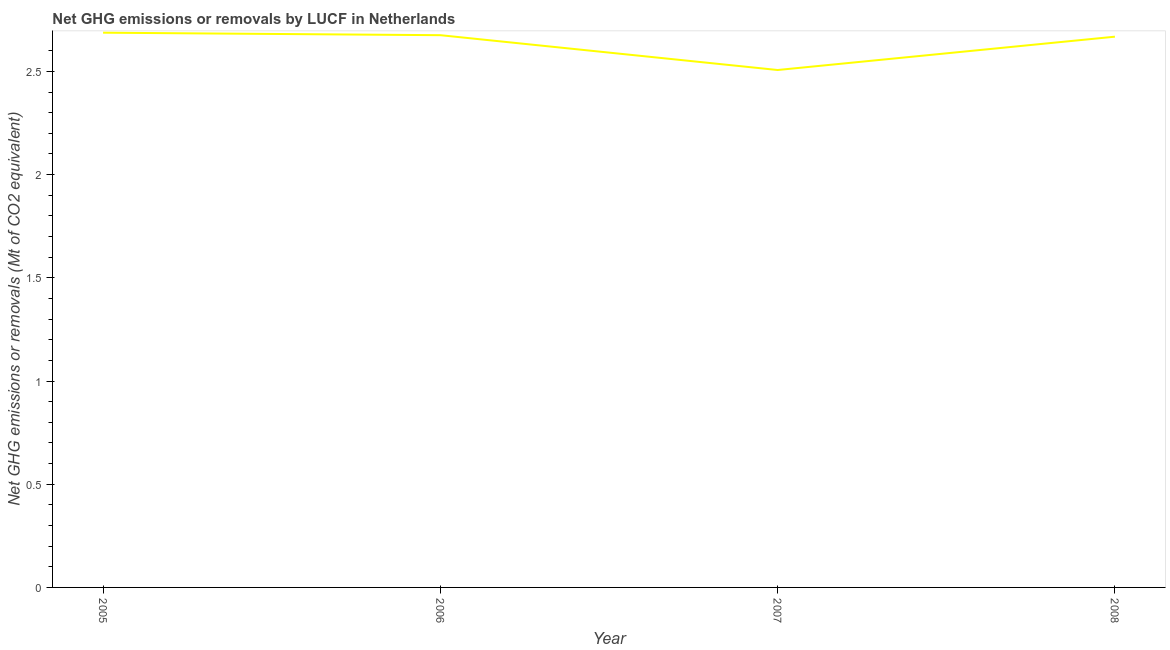What is the ghg net emissions or removals in 2005?
Your answer should be compact. 2.69. Across all years, what is the maximum ghg net emissions or removals?
Offer a terse response. 2.69. Across all years, what is the minimum ghg net emissions or removals?
Provide a succinct answer. 2.51. In which year was the ghg net emissions or removals maximum?
Give a very brief answer. 2005. In which year was the ghg net emissions or removals minimum?
Your response must be concise. 2007. What is the sum of the ghg net emissions or removals?
Your answer should be compact. 10.54. What is the difference between the ghg net emissions or removals in 2006 and 2008?
Your answer should be compact. 0.01. What is the average ghg net emissions or removals per year?
Offer a very short reply. 2.63. What is the median ghg net emissions or removals?
Your answer should be compact. 2.67. In how many years, is the ghg net emissions or removals greater than 0.6 Mt?
Keep it short and to the point. 4. Do a majority of the years between 2005 and 2007 (inclusive) have ghg net emissions or removals greater than 0.1 Mt?
Your answer should be compact. Yes. What is the ratio of the ghg net emissions or removals in 2005 to that in 2007?
Keep it short and to the point. 1.07. Is the difference between the ghg net emissions or removals in 2006 and 2007 greater than the difference between any two years?
Make the answer very short. No. What is the difference between the highest and the second highest ghg net emissions or removals?
Your response must be concise. 0.01. Is the sum of the ghg net emissions or removals in 2005 and 2007 greater than the maximum ghg net emissions or removals across all years?
Make the answer very short. Yes. What is the difference between the highest and the lowest ghg net emissions or removals?
Offer a terse response. 0.18. In how many years, is the ghg net emissions or removals greater than the average ghg net emissions or removals taken over all years?
Your answer should be compact. 3. Does the ghg net emissions or removals monotonically increase over the years?
Ensure brevity in your answer.  No. How many years are there in the graph?
Your response must be concise. 4. Does the graph contain grids?
Ensure brevity in your answer.  No. What is the title of the graph?
Keep it short and to the point. Net GHG emissions or removals by LUCF in Netherlands. What is the label or title of the X-axis?
Give a very brief answer. Year. What is the label or title of the Y-axis?
Offer a very short reply. Net GHG emissions or removals (Mt of CO2 equivalent). What is the Net GHG emissions or removals (Mt of CO2 equivalent) in 2005?
Give a very brief answer. 2.69. What is the Net GHG emissions or removals (Mt of CO2 equivalent) of 2006?
Your response must be concise. 2.68. What is the Net GHG emissions or removals (Mt of CO2 equivalent) of 2007?
Your answer should be very brief. 2.51. What is the Net GHG emissions or removals (Mt of CO2 equivalent) of 2008?
Your answer should be very brief. 2.67. What is the difference between the Net GHG emissions or removals (Mt of CO2 equivalent) in 2005 and 2006?
Provide a short and direct response. 0.01. What is the difference between the Net GHG emissions or removals (Mt of CO2 equivalent) in 2005 and 2007?
Offer a very short reply. 0.18. What is the difference between the Net GHG emissions or removals (Mt of CO2 equivalent) in 2005 and 2008?
Give a very brief answer. 0.02. What is the difference between the Net GHG emissions or removals (Mt of CO2 equivalent) in 2006 and 2007?
Your response must be concise. 0.17. What is the difference between the Net GHG emissions or removals (Mt of CO2 equivalent) in 2006 and 2008?
Give a very brief answer. 0.01. What is the difference between the Net GHG emissions or removals (Mt of CO2 equivalent) in 2007 and 2008?
Make the answer very short. -0.16. What is the ratio of the Net GHG emissions or removals (Mt of CO2 equivalent) in 2005 to that in 2006?
Give a very brief answer. 1. What is the ratio of the Net GHG emissions or removals (Mt of CO2 equivalent) in 2005 to that in 2007?
Offer a very short reply. 1.07. What is the ratio of the Net GHG emissions or removals (Mt of CO2 equivalent) in 2005 to that in 2008?
Make the answer very short. 1.01. What is the ratio of the Net GHG emissions or removals (Mt of CO2 equivalent) in 2006 to that in 2007?
Offer a very short reply. 1.07. What is the ratio of the Net GHG emissions or removals (Mt of CO2 equivalent) in 2007 to that in 2008?
Make the answer very short. 0.94. 